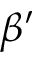Convert formula to latex. <formula><loc_0><loc_0><loc_500><loc_500>\beta ^ { \prime }</formula> 